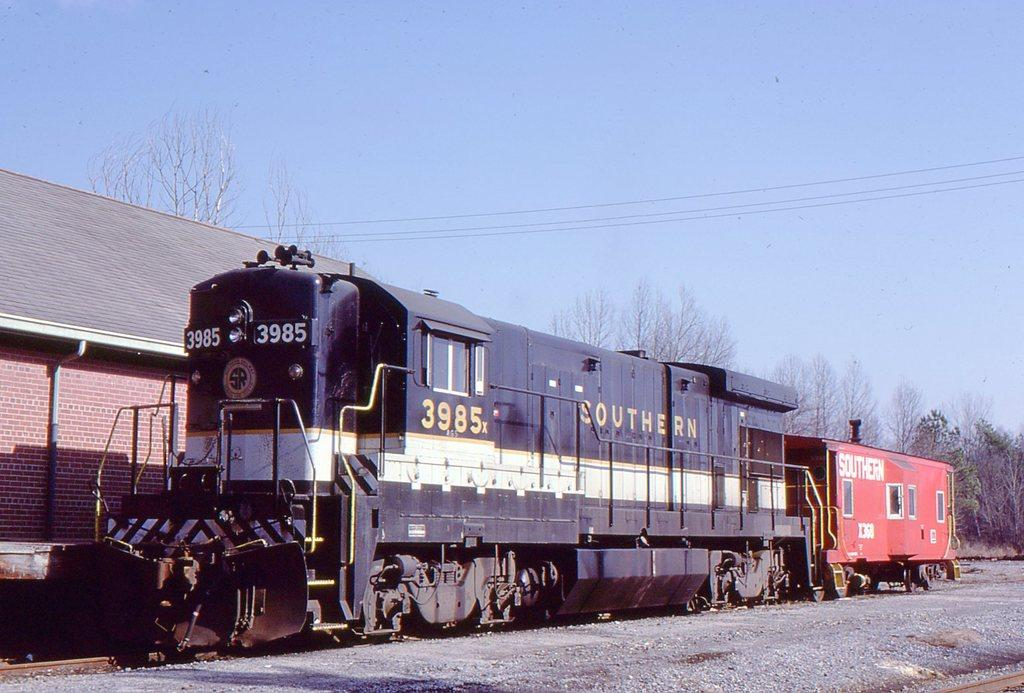What is the main subject of the image? The main subject of the image is a train on the track. What can be seen in the background of the image? The sky is visible in the background of the image. What type of vegetation is present in the image? There are trees in the image. What other objects can be seen in the image? There are stones, wires, and a building in the image. Can you see a whip being used on a neck in the image? No, there is no whip or any indication of a neck being used in the image. The image features a train on a track, trees, stones, wires, and a building. 